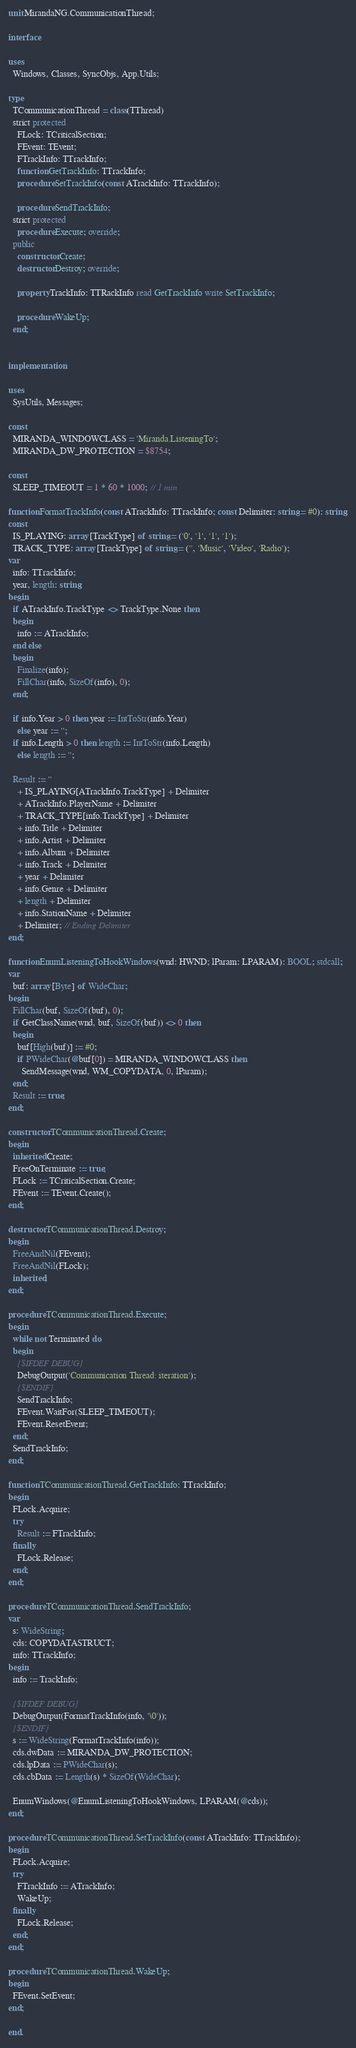<code> <loc_0><loc_0><loc_500><loc_500><_Pascal_>unit MirandaNG.CommunicationThread;

interface

uses
  Windows, Classes, SyncObjs, App.Utils;

type
  TCommunicationThread = class(TThread)
  strict protected
    FLock: TCriticalSection;
    FEvent: TEvent;
    FTrackInfo: TTrackInfo;
    function GetTrackInfo: TTrackInfo;
    procedure SetTrackInfo(const ATrackInfo: TTrackInfo);

    procedure SendTrackInfo;
  strict protected
    procedure Execute; override;
  public
    constructor Create;
    destructor Destroy; override;

    property TrackInfo: TTRackInfo read GetTrackInfo write SetTrackInfo;

    procedure WakeUp;
  end;


implementation

uses
  SysUtils, Messages;

const
  MIRANDA_WINDOWCLASS = 'Miranda.ListeningTo';
  MIRANDA_DW_PROTECTION = $8754;

const
  SLEEP_TIMEOUT = 1 * 60 * 1000; // 1 min

function FormatTrackInfo(const ATrackInfo: TTrackInfo; const Delimiter: string = #0): string;
const
  IS_PLAYING: array [TrackType] of string = ('0', '1', '1', '1');
  TRACK_TYPE: array [TrackType] of string = ('', 'Music', 'Video', 'Radio');
var
  info: TTrackInfo;
  year, length: string;
begin
  if ATrackInfo.TrackType <> TrackType.None then
  begin
    info := ATrackInfo;
  end else
  begin
    Finalize(info);
    FillChar(info, SizeOf(info), 0);
  end;

  if info.Year > 0 then year := IntToStr(info.Year)
    else year := '';
  if info.Length > 0 then length := IntToStr(info.Length)
    else length := '';

  Result := ''
    + IS_PLAYING[ATrackInfo.TrackType] + Delimiter
    + ATrackInfo.PlayerName + Delimiter
    + TRACK_TYPE[info.TrackType] + Delimiter
    + info.Title + Delimiter
    + info.Artist + Delimiter
    + info.Album + Delimiter
    + info.Track + Delimiter
    + year + Delimiter
    + info.Genre + Delimiter
    + length + Delimiter
    + info.StationName + Delimiter
    + Delimiter; // Ending Delimiter
end;

function EnumListeningToHookWindows(wnd: HWND; lParam: LPARAM): BOOL; stdcall;
var
  buf: array [Byte] of WideChar;
begin
  FillChar(buf, SizeOf(buf), 0);
  if GetClassName(wnd, buf, SizeOf(buf)) <> 0 then
  begin
    buf[High(buf)] := #0;
    if PWideChar(@buf[0]) = MIRANDA_WINDOWCLASS then
      SendMessage(wnd, WM_COPYDATA, 0, lParam);
  end;
  Result := true;
end;

constructor TCommunicationThread.Create;
begin
  inherited Create;
  FreeOnTerminate := true;
  FLock := TCriticalSection.Create;
  FEvent := TEvent.Create();
end;

destructor TCommunicationThread.Destroy;
begin
  FreeAndNil(FEvent);
  FreeAndNil(FLock);
  inherited;
end;

procedure TCommunicationThread.Execute;
begin
  while not Terminated do
  begin
    {$IFDEF DEBUG}
    DebugOutput('Communication Thread: iteration');
    {$ENDIF}
    SendTrackInfo;
    FEvent.WaitFor(SLEEP_TIMEOUT);
    FEvent.ResetEvent;
  end;
  SendTrackInfo;
end;

function TCommunicationThread.GetTrackInfo: TTrackInfo;
begin
  FLock.Acquire;
  try
    Result := FTrackInfo;
  finally
    FLock.Release;
  end;
end;

procedure TCommunicationThread.SendTrackInfo;
var
  s: WideString;
  cds: COPYDATASTRUCT;
  info: TTrackInfo;
begin
  info := TrackInfo;

  {$IFDEF DEBUG}
  DebugOutput(FormatTrackInfo(info, '\0'));
  {$ENDIF}
  s := WideString(FormatTrackInfo(info));
  cds.dwData := MIRANDA_DW_PROTECTION;
  cds.lpData := PWideChar(s);
  cds.cbData := Length(s) * SizeOf(WideChar);

  EnumWindows(@EnumListeningToHookWindows, LPARAM(@cds));
end;

procedure TCommunicationThread.SetTrackInfo(const ATrackInfo: TTrackInfo);
begin
  FLock.Acquire;
  try
    FTrackInfo := ATrackInfo;
    WakeUp;
  finally
    FLock.Release;
  end;
end;

procedure TCommunicationThread.WakeUp;
begin
  FEvent.SetEvent;
end;

end.
</code> 